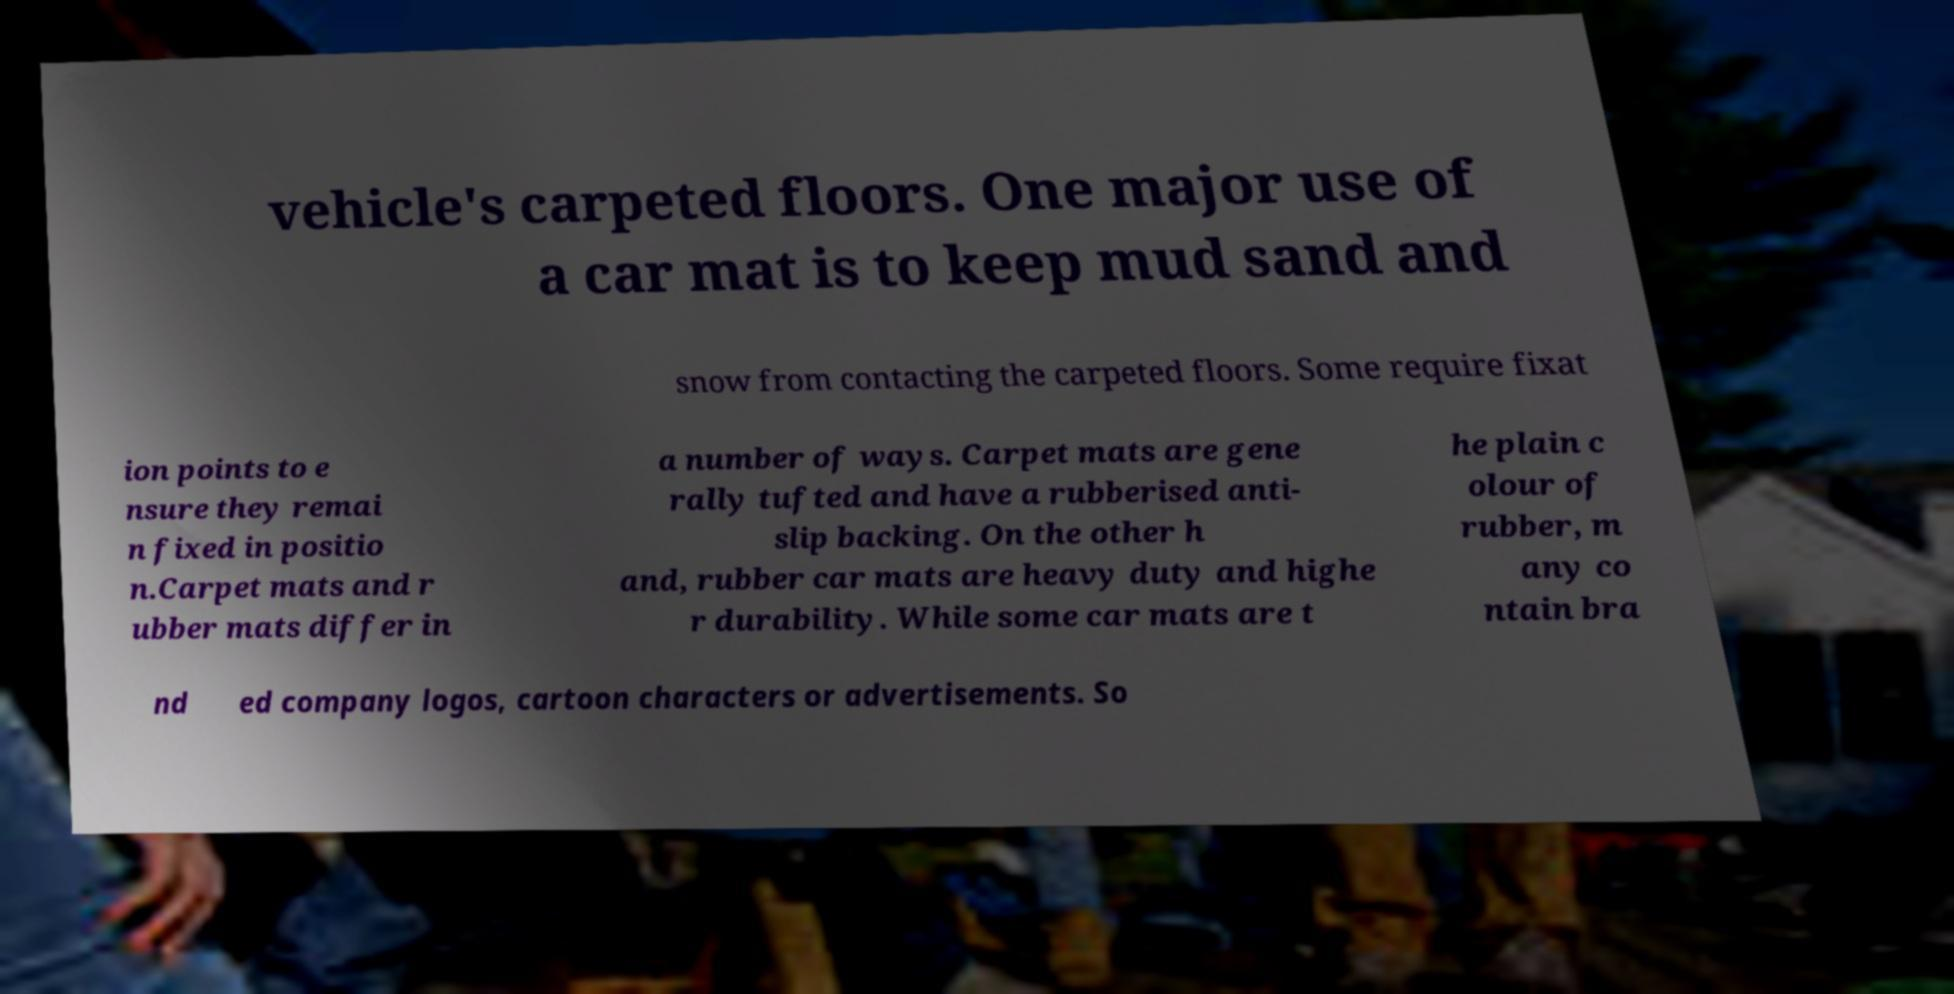For documentation purposes, I need the text within this image transcribed. Could you provide that? vehicle's carpeted floors. One major use of a car mat is to keep mud sand and snow from contacting the carpeted floors. Some require fixat ion points to e nsure they remai n fixed in positio n.Carpet mats and r ubber mats differ in a number of ways. Carpet mats are gene rally tufted and have a rubberised anti- slip backing. On the other h and, rubber car mats are heavy duty and highe r durability. While some car mats are t he plain c olour of rubber, m any co ntain bra nd ed company logos, cartoon characters or advertisements. So 